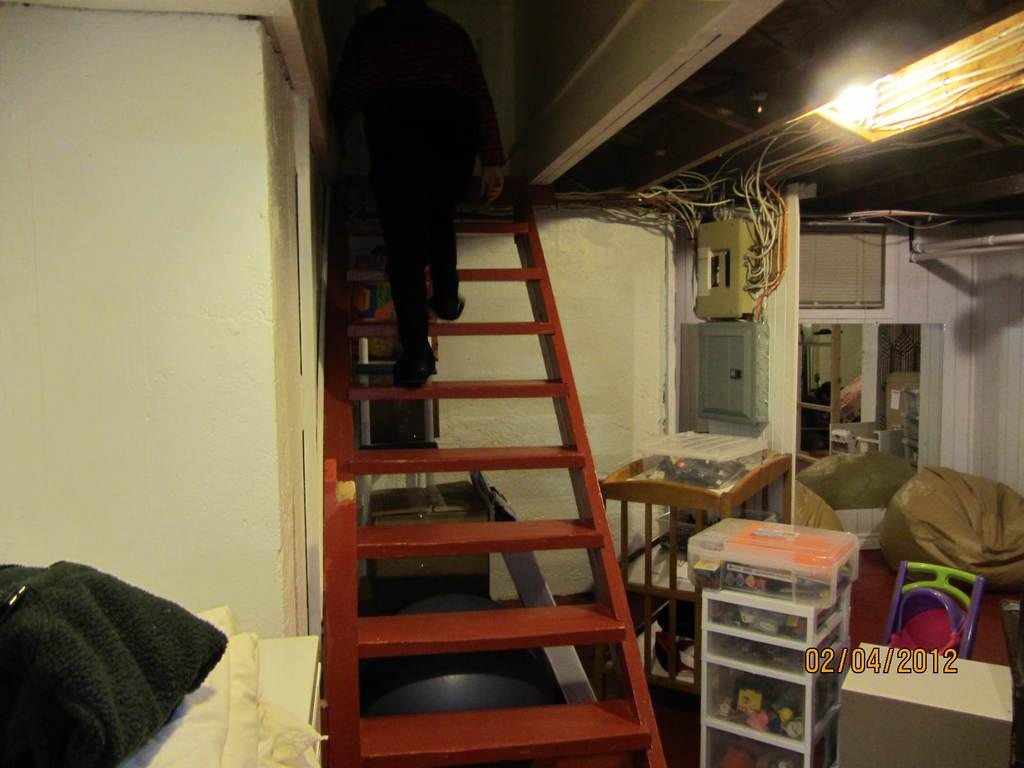Where is the setting of the image? The image is inside a room. What is the person in the image doing? The person is on steps. What is the source of light in the image? There is a light on top. What type of equipment is present in the image? Cables and a box on a cart are present. What type of seating is in the image? There is a bean bag. What color is the wall in the image? The wall is white. What type of mint is growing on the white wall in the image? There is no mint growing on the white wall in the image; the wall is white and there are no plants visible. 